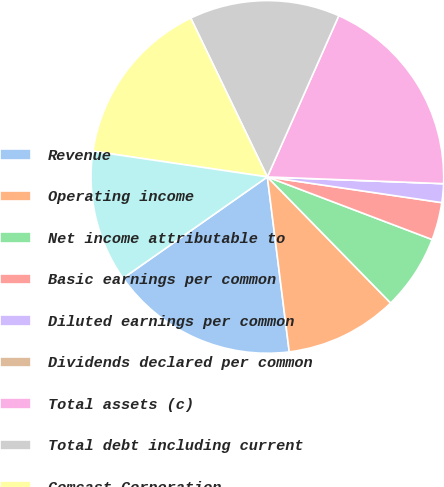<chart> <loc_0><loc_0><loc_500><loc_500><pie_chart><fcel>Revenue<fcel>Operating income<fcel>Net income attributable to<fcel>Basic earnings per common<fcel>Diluted earnings per common<fcel>Dividends declared per common<fcel>Total assets (c)<fcel>Total debt including current<fcel>Comcast Corporation<fcel>Operating activities<nl><fcel>17.24%<fcel>10.34%<fcel>6.9%<fcel>3.45%<fcel>1.72%<fcel>0.0%<fcel>18.97%<fcel>13.79%<fcel>15.52%<fcel>12.07%<nl></chart> 